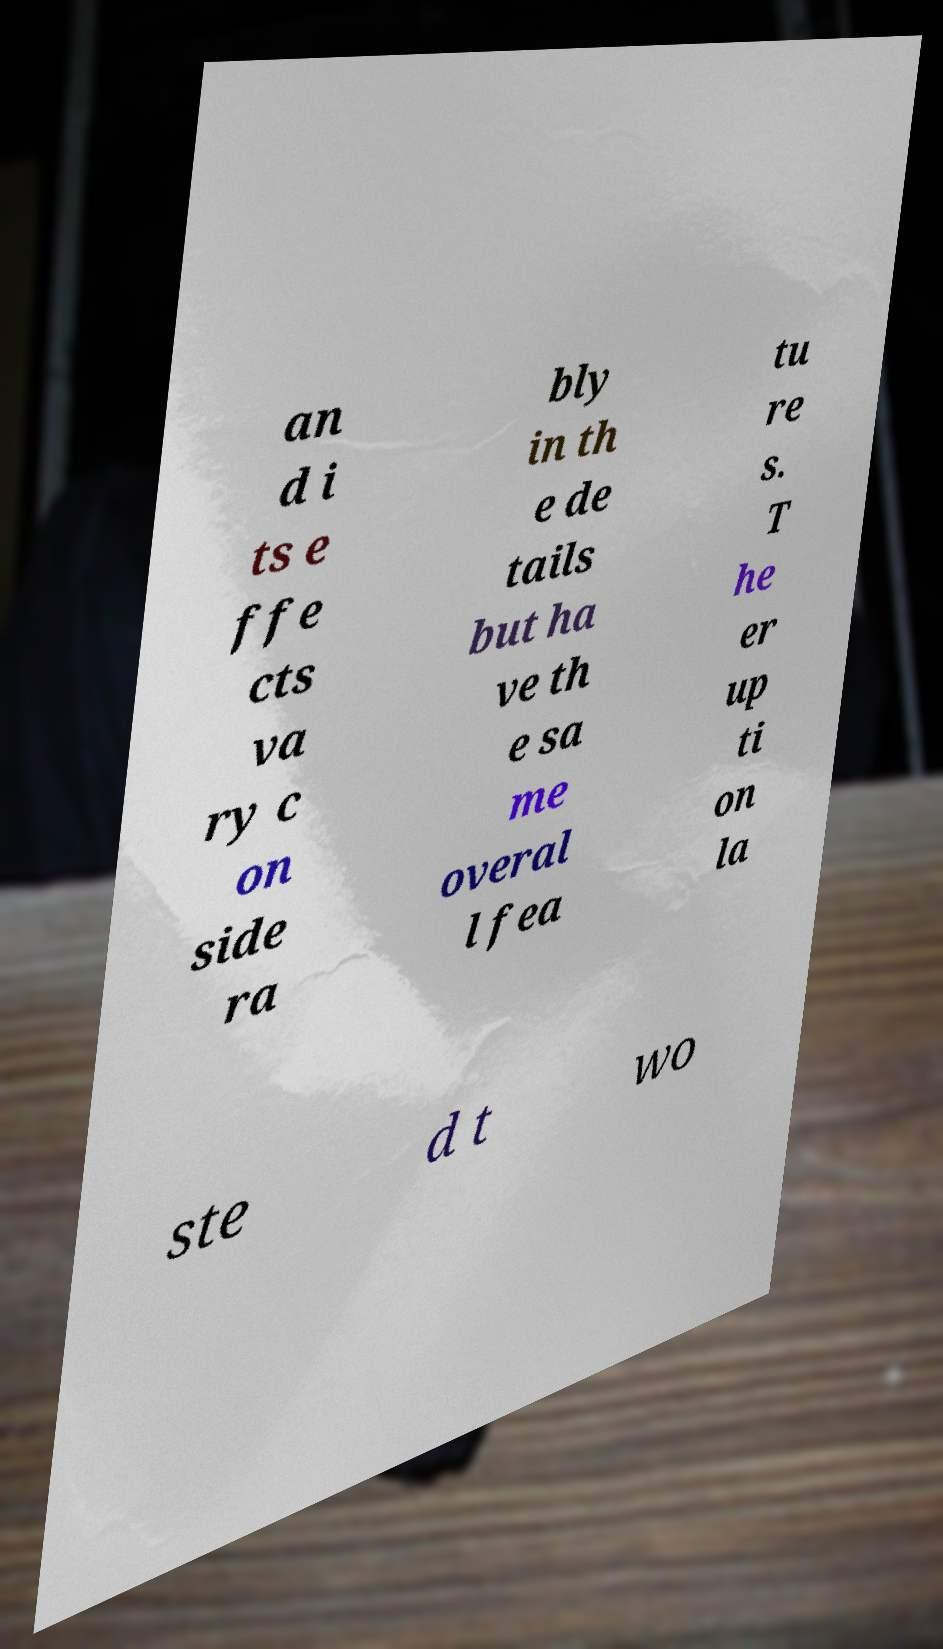There's text embedded in this image that I need extracted. Can you transcribe it verbatim? an d i ts e ffe cts va ry c on side ra bly in th e de tails but ha ve th e sa me overal l fea tu re s. T he er up ti on la ste d t wo 